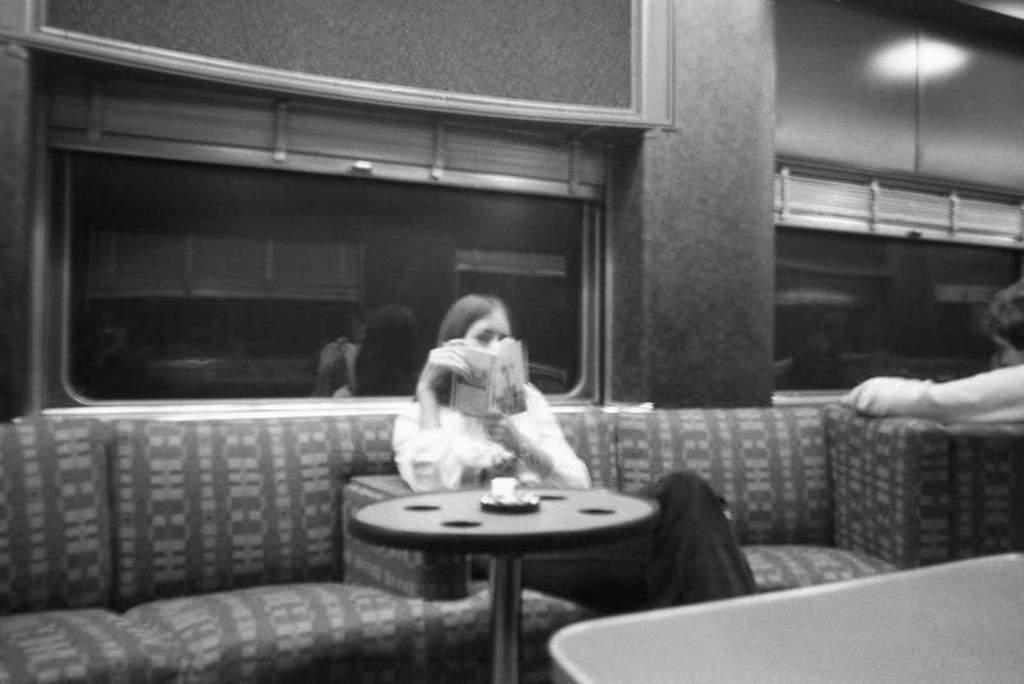Please provide a concise description of this image. It is a black and white image, in this a woman is sitting on the sofa and reading the book, there are window glasses in this image. 